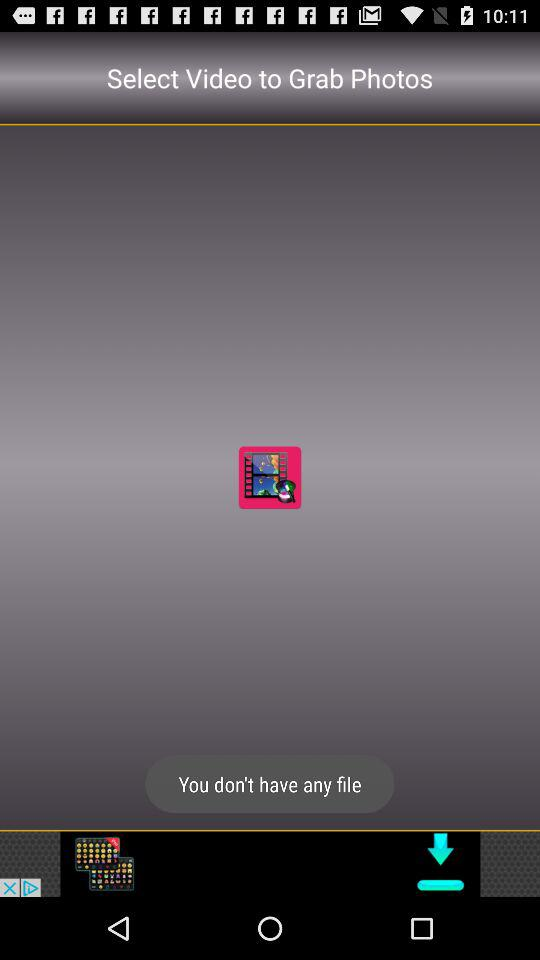Do we have any files? You don't have any files. 